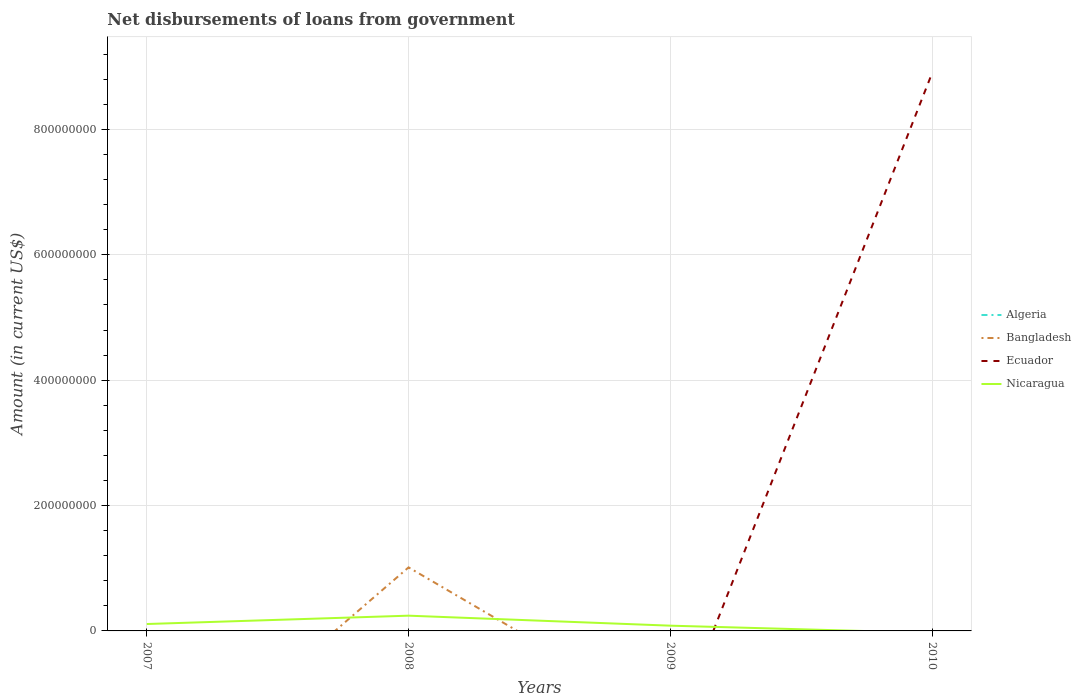What is the total amount of loan disbursed from government in Nicaragua in the graph?
Provide a succinct answer. -1.33e+07. What is the difference between the highest and the second highest amount of loan disbursed from government in Ecuador?
Give a very brief answer. 8.90e+08. How many years are there in the graph?
Offer a very short reply. 4. What is the difference between two consecutive major ticks on the Y-axis?
Offer a very short reply. 2.00e+08. Are the values on the major ticks of Y-axis written in scientific E-notation?
Make the answer very short. No. Does the graph contain grids?
Provide a short and direct response. Yes. How are the legend labels stacked?
Provide a short and direct response. Vertical. What is the title of the graph?
Offer a very short reply. Net disbursements of loans from government. What is the label or title of the X-axis?
Offer a very short reply. Years. What is the Amount (in current US$) in Algeria in 2007?
Ensure brevity in your answer.  0. What is the Amount (in current US$) in Nicaragua in 2007?
Offer a very short reply. 1.10e+07. What is the Amount (in current US$) in Bangladesh in 2008?
Provide a succinct answer. 1.01e+08. What is the Amount (in current US$) in Nicaragua in 2008?
Provide a short and direct response. 2.43e+07. What is the Amount (in current US$) in Algeria in 2009?
Offer a very short reply. 0. What is the Amount (in current US$) in Bangladesh in 2009?
Provide a short and direct response. 0. What is the Amount (in current US$) of Ecuador in 2009?
Ensure brevity in your answer.  0. What is the Amount (in current US$) of Nicaragua in 2009?
Your answer should be very brief. 8.36e+06. What is the Amount (in current US$) in Algeria in 2010?
Ensure brevity in your answer.  0. What is the Amount (in current US$) of Bangladesh in 2010?
Your answer should be compact. 0. What is the Amount (in current US$) of Ecuador in 2010?
Keep it short and to the point. 8.90e+08. Across all years, what is the maximum Amount (in current US$) in Bangladesh?
Your response must be concise. 1.01e+08. Across all years, what is the maximum Amount (in current US$) in Ecuador?
Offer a terse response. 8.90e+08. Across all years, what is the maximum Amount (in current US$) in Nicaragua?
Keep it short and to the point. 2.43e+07. Across all years, what is the minimum Amount (in current US$) of Nicaragua?
Offer a very short reply. 0. What is the total Amount (in current US$) of Algeria in the graph?
Your answer should be very brief. 0. What is the total Amount (in current US$) in Bangladesh in the graph?
Make the answer very short. 1.01e+08. What is the total Amount (in current US$) in Ecuador in the graph?
Provide a succinct answer. 8.90e+08. What is the total Amount (in current US$) in Nicaragua in the graph?
Your answer should be compact. 4.37e+07. What is the difference between the Amount (in current US$) of Nicaragua in 2007 and that in 2008?
Your answer should be compact. -1.33e+07. What is the difference between the Amount (in current US$) in Nicaragua in 2007 and that in 2009?
Offer a very short reply. 2.65e+06. What is the difference between the Amount (in current US$) of Nicaragua in 2008 and that in 2009?
Keep it short and to the point. 1.60e+07. What is the difference between the Amount (in current US$) of Bangladesh in 2008 and the Amount (in current US$) of Nicaragua in 2009?
Your answer should be very brief. 9.30e+07. What is the difference between the Amount (in current US$) of Bangladesh in 2008 and the Amount (in current US$) of Ecuador in 2010?
Keep it short and to the point. -7.89e+08. What is the average Amount (in current US$) in Algeria per year?
Your answer should be very brief. 0. What is the average Amount (in current US$) of Bangladesh per year?
Give a very brief answer. 2.53e+07. What is the average Amount (in current US$) of Ecuador per year?
Offer a terse response. 2.23e+08. What is the average Amount (in current US$) of Nicaragua per year?
Keep it short and to the point. 1.09e+07. In the year 2008, what is the difference between the Amount (in current US$) in Bangladesh and Amount (in current US$) in Nicaragua?
Your response must be concise. 7.70e+07. What is the ratio of the Amount (in current US$) in Nicaragua in 2007 to that in 2008?
Provide a succinct answer. 0.45. What is the ratio of the Amount (in current US$) of Nicaragua in 2007 to that in 2009?
Give a very brief answer. 1.32. What is the ratio of the Amount (in current US$) in Nicaragua in 2008 to that in 2009?
Offer a terse response. 2.91. What is the difference between the highest and the second highest Amount (in current US$) in Nicaragua?
Give a very brief answer. 1.33e+07. What is the difference between the highest and the lowest Amount (in current US$) of Bangladesh?
Make the answer very short. 1.01e+08. What is the difference between the highest and the lowest Amount (in current US$) of Ecuador?
Offer a terse response. 8.90e+08. What is the difference between the highest and the lowest Amount (in current US$) of Nicaragua?
Provide a short and direct response. 2.43e+07. 